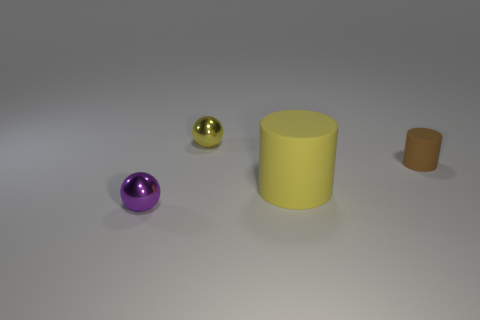What size is the ball behind the metallic ball left of the ball that is to the right of the purple sphere?
Your answer should be very brief. Small. Is the material of the big yellow object the same as the ball behind the small brown rubber object?
Make the answer very short. No. What size is the brown cylinder that is the same material as the big thing?
Your answer should be very brief. Small. Are there any small brown rubber things that have the same shape as the purple object?
Keep it short and to the point. No. How many objects are either spheres in front of the tiny brown matte cylinder or tiny gray balls?
Provide a succinct answer. 1. What is the size of the object that is the same color as the big cylinder?
Offer a very short reply. Small. Does the small sphere that is in front of the small brown cylinder have the same color as the matte cylinder that is behind the big thing?
Your answer should be compact. No. The yellow metal object has what size?
Ensure brevity in your answer.  Small. What number of small things are cylinders or yellow objects?
Your response must be concise. 2. There is a cylinder that is the same size as the yellow metallic thing; what is its color?
Your response must be concise. Brown. 